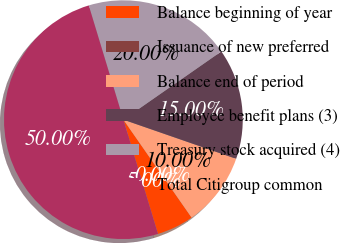Convert chart. <chart><loc_0><loc_0><loc_500><loc_500><pie_chart><fcel>Balance beginning of year<fcel>Issuance of new preferred<fcel>Balance end of period<fcel>Employee benefit plans (3)<fcel>Treasury stock acquired (4)<fcel>Total Citigroup common<nl><fcel>5.0%<fcel>0.0%<fcel>10.0%<fcel>15.0%<fcel>20.0%<fcel>50.0%<nl></chart> 